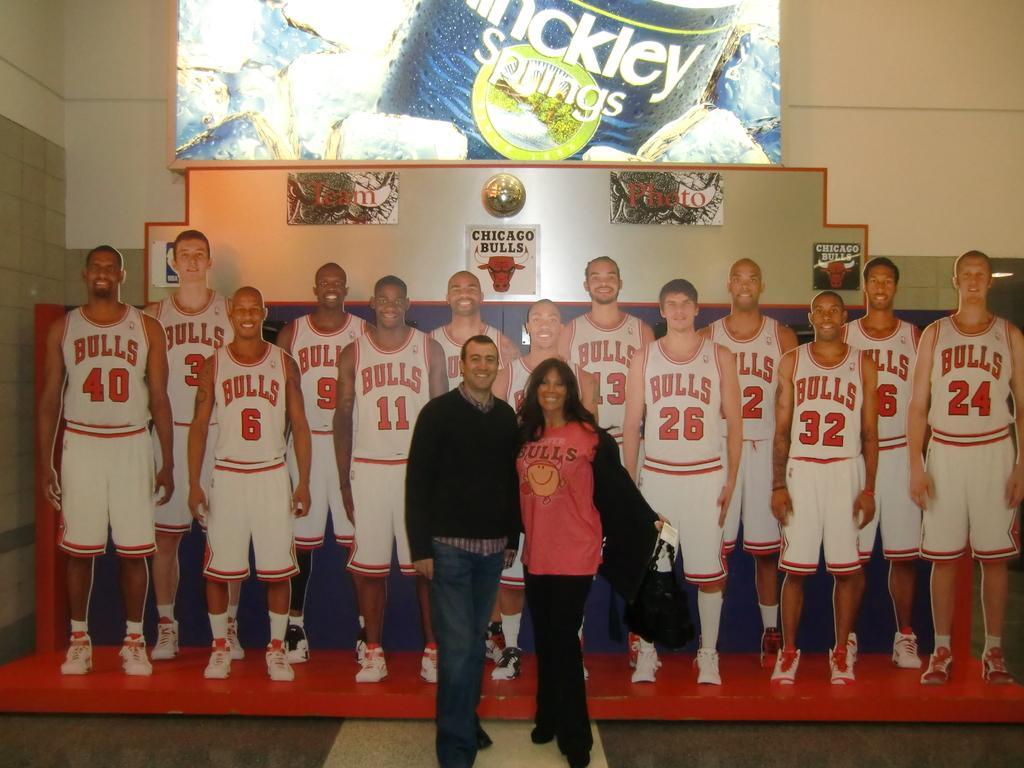Describe this image in one or two sentences. In this image I can see a person wearing black and blue colored dress and woman wearing pink and black colored dress are standing and I can see the woman is holding a black colored bag. I can see a huge banner behind them in which I can see number of persons are wearing white and red color jersey are standing. In the background I can see the cream colored wall and a huge board attached to the wall. 